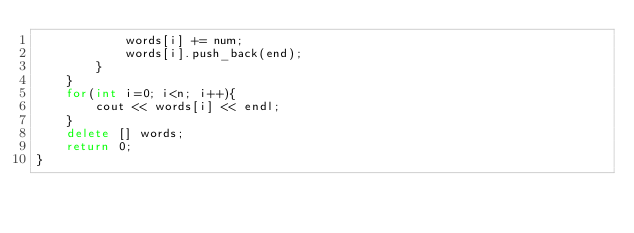<code> <loc_0><loc_0><loc_500><loc_500><_C++_>			words[i] += num;
			words[i].push_back(end);
		}
	}
	for(int i=0; i<n; i++){
		cout << words[i] << endl;
	}
	delete [] words;
	return 0;
}
</code> 